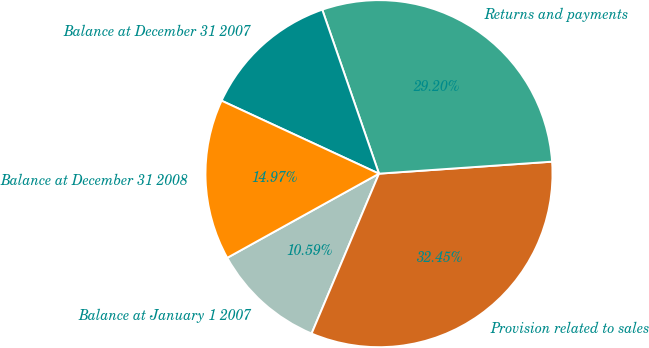<chart> <loc_0><loc_0><loc_500><loc_500><pie_chart><fcel>Balance at January 1 2007<fcel>Provision related to sales<fcel>Returns and payments<fcel>Balance at December 31 2007<fcel>Balance at December 31 2008<nl><fcel>10.59%<fcel>32.45%<fcel>29.2%<fcel>12.79%<fcel>14.97%<nl></chart> 